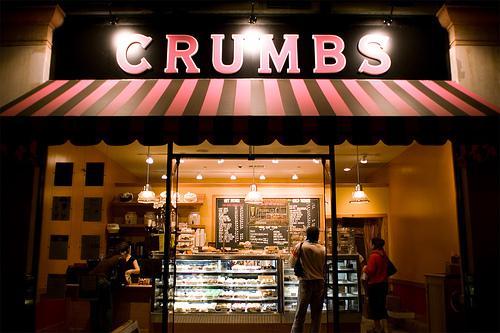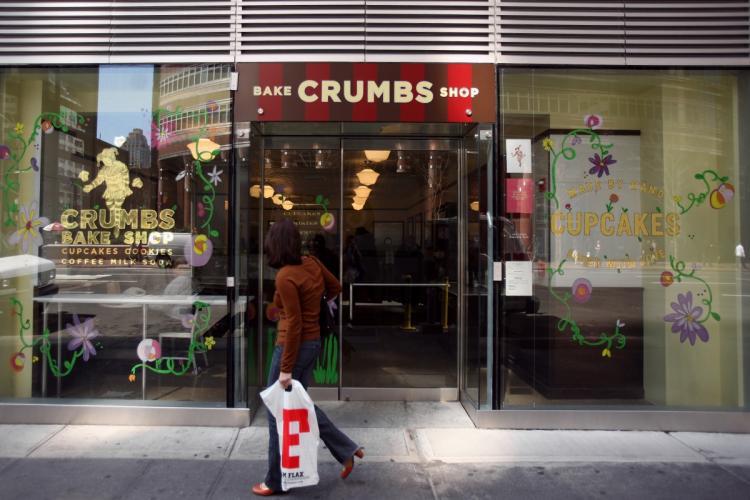The first image is the image on the left, the second image is the image on the right. Given the left and right images, does the statement "A red and black awning hangs over the entrance in the image on the left." hold true? Answer yes or no. Yes. 